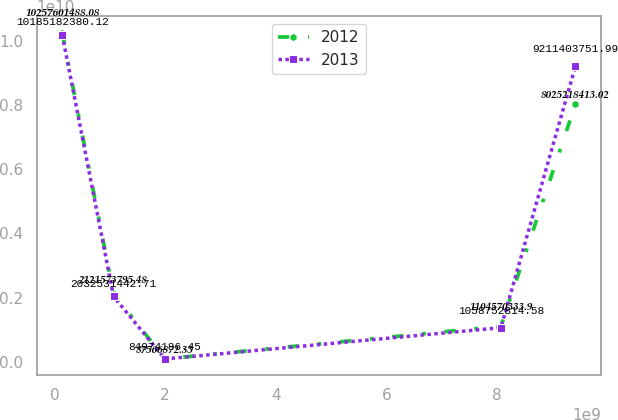Convert chart to OTSL. <chart><loc_0><loc_0><loc_500><loc_500><line_chart><ecel><fcel>2012<fcel>2013<nl><fcel>1.426e+08<fcel>1.02576e+10<fcel>1.01852e+10<nl><fcel>1.06976e+09<fcel>2.12157e+09<fcel>2.03253e+09<nl><fcel>1.99692e+09<fcel>8.75669e+07<fcel>8.49742e+07<nl><fcel>8.06692e+09<fcel>1.10457e+09<fcel>1.05875e+09<nl><fcel>9.41419e+09<fcel>8.02522e+09<fcel>9.2114e+09<nl></chart> 